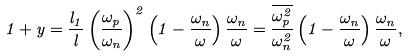Convert formula to latex. <formula><loc_0><loc_0><loc_500><loc_500>1 + y = \frac { l _ { 1 } } { l } \left ( \frac { \omega _ { p } } { \omega _ { n } } \right ) ^ { 2 } \left ( 1 - \frac { \omega _ { n } } { \omega } \right ) \frac { \omega _ { n } } { \omega } = \frac { \overline { \omega _ { p } ^ { 2 } } } { \omega _ { n } ^ { 2 } } \left ( 1 - \frac { \omega _ { n } } { \omega } \right ) \frac { \omega _ { n } } { \omega } ,</formula> 